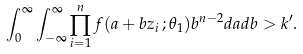<formula> <loc_0><loc_0><loc_500><loc_500>\int _ { 0 } ^ { \infty } \int _ { - \infty } ^ { \infty } \prod _ { i = 1 } ^ { n } f ( a + b z _ { i } \, ; \theta _ { 1 } ) b ^ { n - 2 } d a d b > k ^ { \prime } .</formula> 